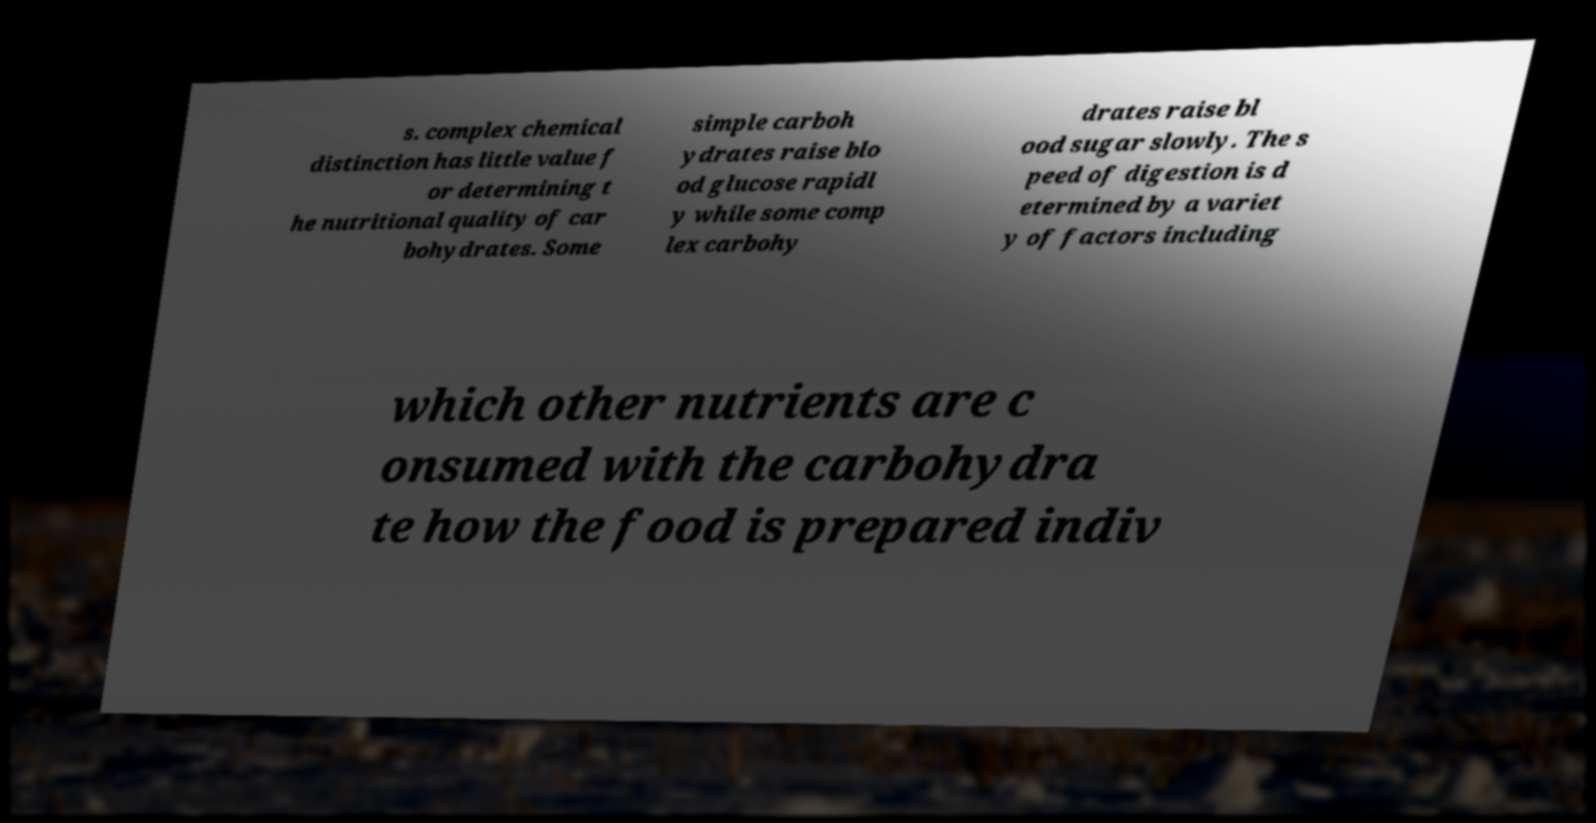Please identify and transcribe the text found in this image. s. complex chemical distinction has little value f or determining t he nutritional quality of car bohydrates. Some simple carboh ydrates raise blo od glucose rapidl y while some comp lex carbohy drates raise bl ood sugar slowly. The s peed of digestion is d etermined by a variet y of factors including which other nutrients are c onsumed with the carbohydra te how the food is prepared indiv 